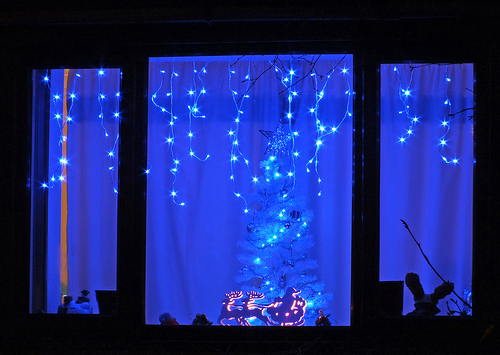<image>
Is there a lights on the stripe? Yes. Looking at the image, I can see the lights is positioned on top of the stripe, with the stripe providing support. 